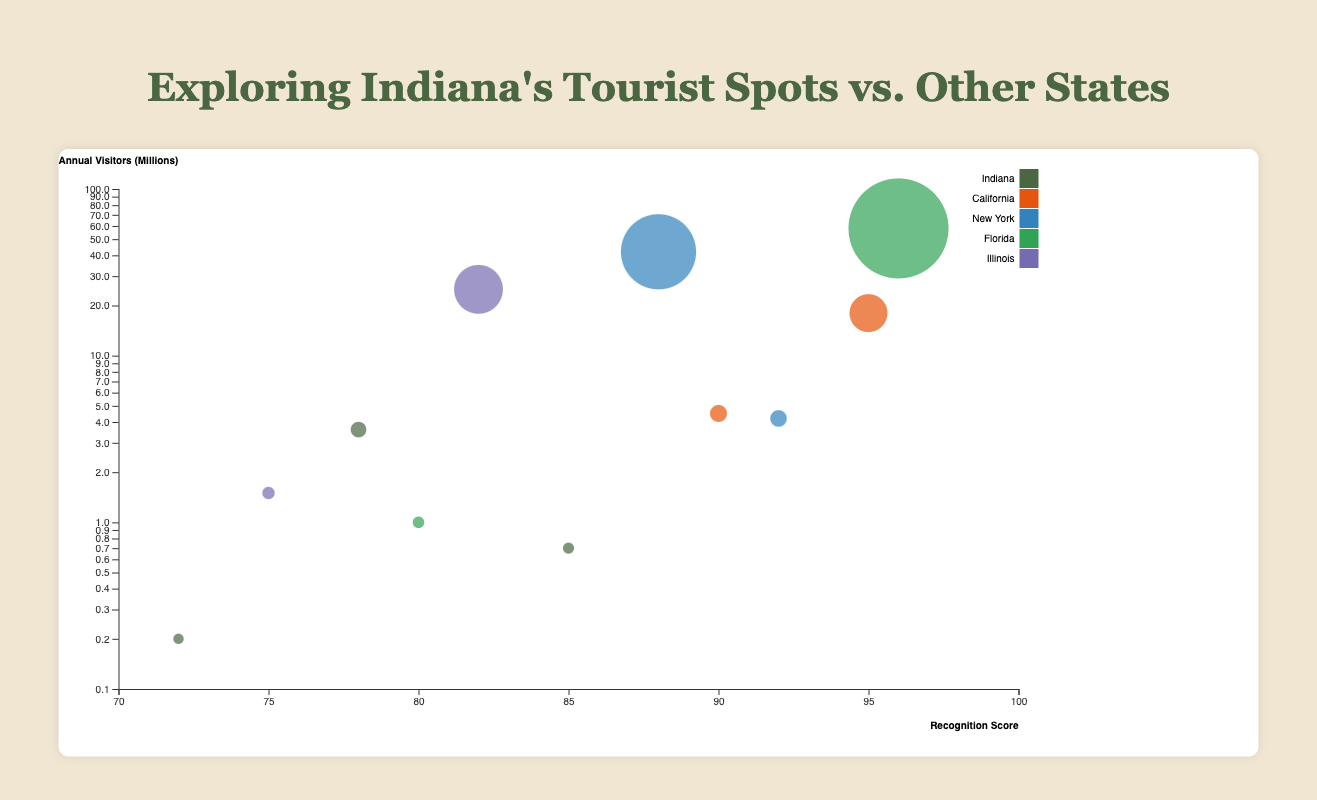How many tourist spots from Indiana are represented in the chart? There are three circles associated with Indiana: "Indiana Dunes National Park", "Indianapolis Motor Speedway Museum", and "Eiteljorg Museum".
Answer: 3 Which tourist spot has the highest recognition score? By locating the highest score on the x-axis (Recognition Score), we see that "Walt Disney World" from Florida has a score of 96.
Answer: Walt Disney World Which state has the tourist spot with the largest annual visitor count? By comparing the size of the circles (which indicate annual visitors), "Walt Disney World" in Florida has the largest circle, corresponding to 58 million visitors annually.
Answer: Florida What is the recognition score range of Indiana's tourist spots? The recognition scores for Indiana's spots are 72 (Eiteljorg Museum), 78 (Indiana Dunes National Park), and 85 (Indianapolis Motor Speedway Museum). Thus, the range is from 72 to 85.
Answer: 72 to 85 Which tourist spot in Indiana has the lowest annual visitors count? Among Indiana's tourist spots, "Eiteljorg Museum" has the smallest circle for annual visitors, which is 0.2 million.
Answer: Eiteljorg Museum How does the recognition score of "Central Park" compare to that of "Millennium Park"? "Central Park" has a recognition score of 88, and "Millennium Park" has a recognition score of 82. Hence, "Central Park" has a higher recognition score.
Answer: Central Park has a higher score What is the total number of visitors (in millions) for the tourist spots in California? The annual visitors for California's spots are 18 million (Disneyland) and 4.5 million (Yosemite National Park). Summing these up, 18 + 4.5 equals 22.5 million visitors.
Answer: 22.5 Which state, other than Indiana, has the highest number of tourist spots on the chart? By counting the tourist spots for each state, we see that Florida, California, New York, and Illinois each have two tourist spots. So, they all have the highest number except Indiana, which has three.
Answer: Florida, California, New York, Illinois Is there a tourist spot with a recognition score between 80 and 85 and an annual visitors count greater than 1 million? “Millennium Park” in Illinois has a recognition score of 82 and annual visitors of 25 million, which lies within the given range.
Answer: Millennium Park Which tourist spot in New York has a higher annual visitor count? Between the "Statue of Liberty" and "Central Park", "Central Park" has considerably more annual visitors (42 million) compared to the "Statue of Liberty" (4.2 million).
Answer: Central Park 